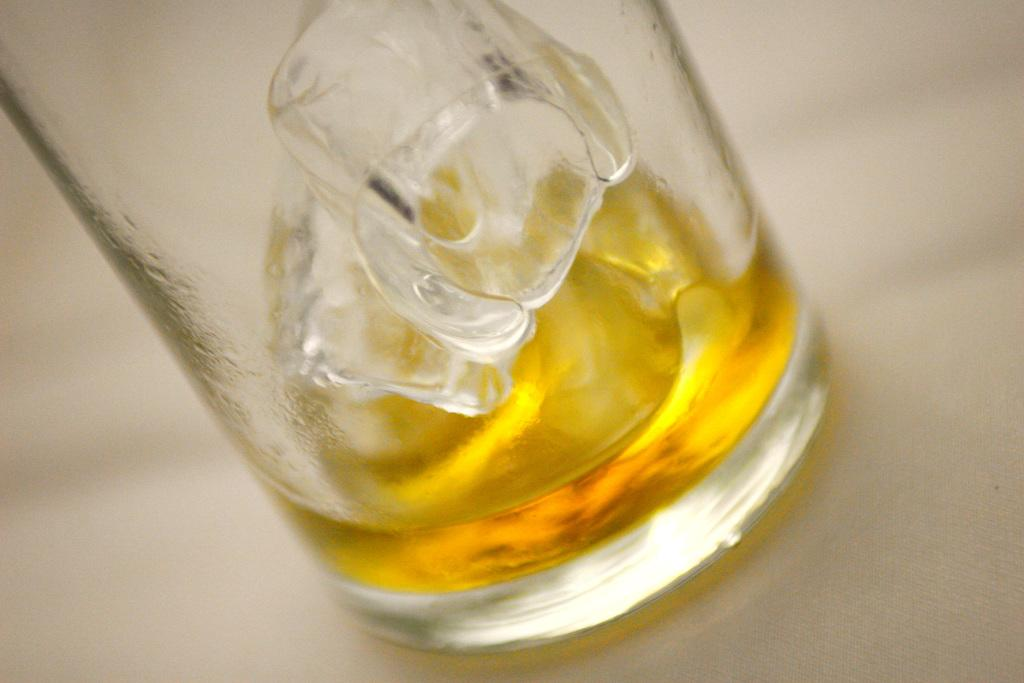What is present on the table in the image? There is a glass on the table in the image. What is inside the glass? There are two ice cubes in the glass, and there is juice in the glass. What type of thunder can be heard in the image? There is no thunder present in the image; it is a still image and does not contain any sounds. 